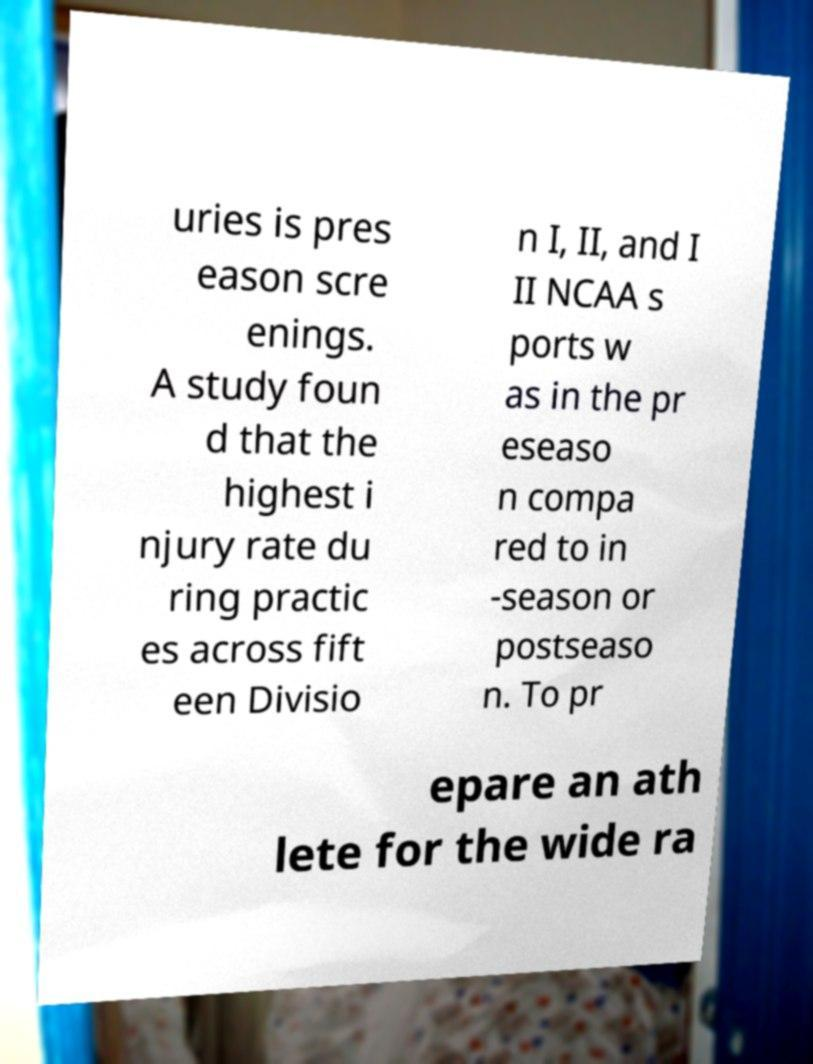Can you read and provide the text displayed in the image?This photo seems to have some interesting text. Can you extract and type it out for me? uries is pres eason scre enings. A study foun d that the highest i njury rate du ring practic es across fift een Divisio n I, II, and I II NCAA s ports w as in the pr eseaso n compa red to in -season or postseaso n. To pr epare an ath lete for the wide ra 